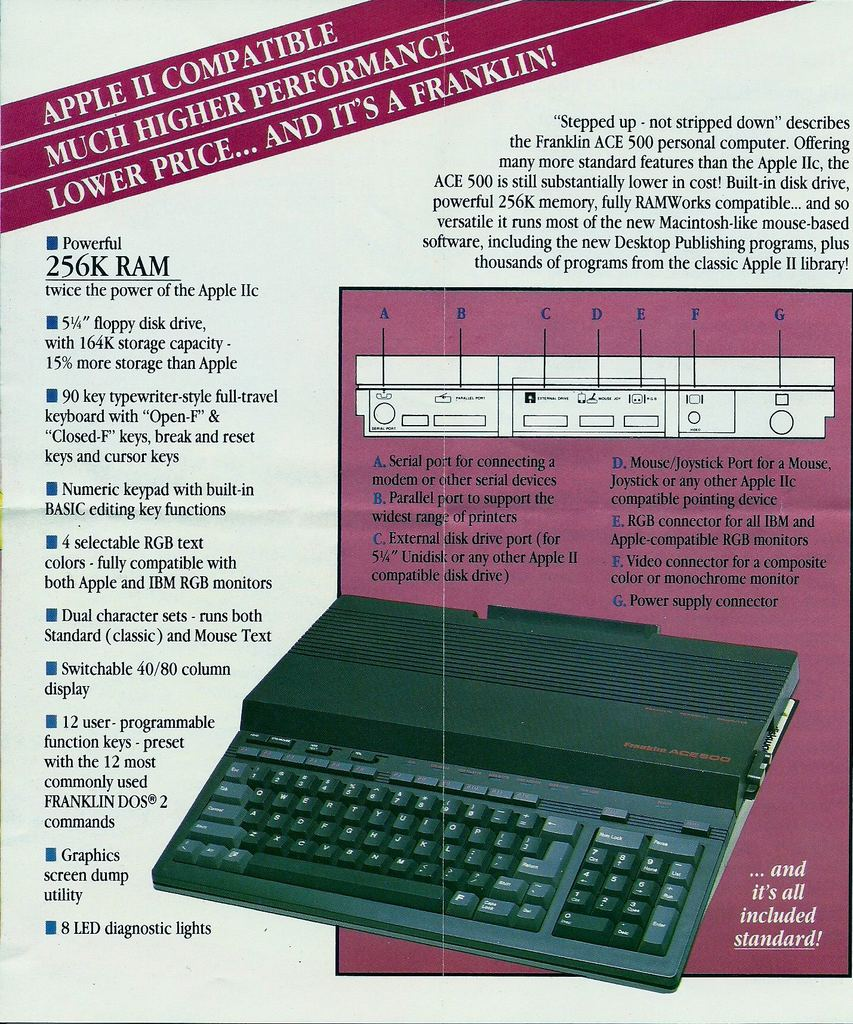How did the compatibility with Apple II impact the Franklin ACE 500's market performance? Compatibility with Apple II was a crucial selling point for the Franklin ACE 500 as it allowed users to access the established library of Apple II software, ensuring a seamless transition for customers switching from an Apple machine. This compatibility likely broadened the ACE 500's appeal, making it attractive to a larger audience looking for high-performance at a more affordable price, which could positively influence its market performance. 